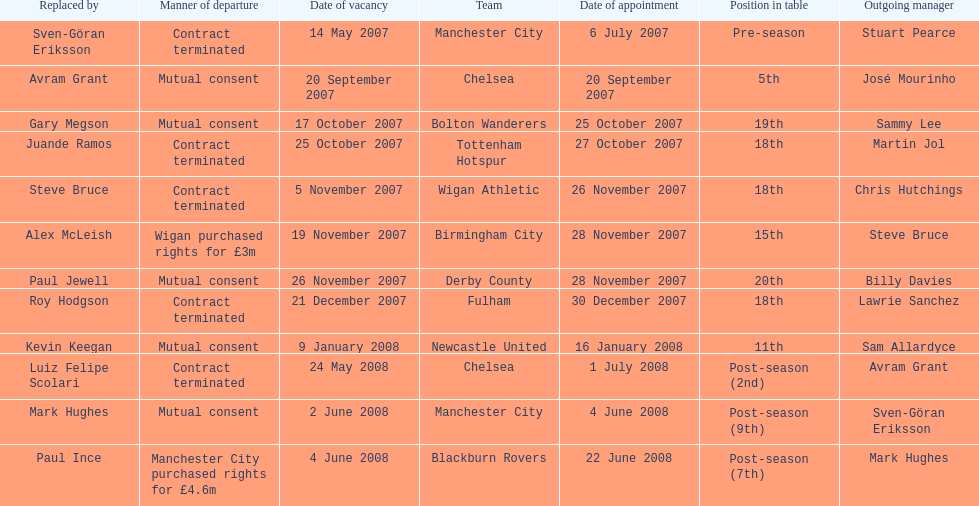What team is listed after manchester city? Chelsea. 